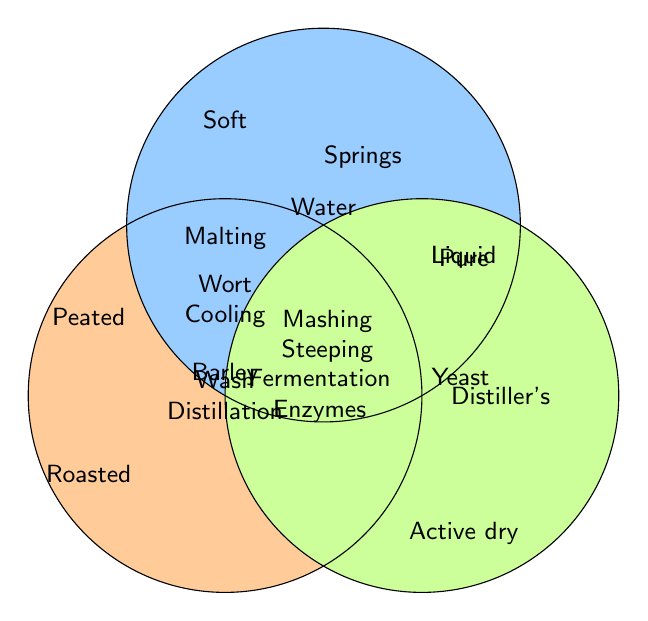What are the main ingredients shown in the Venn Diagram? The Venn Diagram shows three main ingredients as labeled segments: Barley, Water, and Yeast.
Answer: Barley, Water, Yeast Which ingredient is associated with the process 'Springs'? The process 'Springs' is placed inside the circle labeled 'Water'.
Answer: Water Which processes are shared by Barley and Yeast but not Water? The shared processes for Barley and Yeast but not Water are listed in the section overlapping Barley and Yeast circles: Mashing and Steeping.
Answer: Mashing, Steeping How many processes are exclusive to Yeast? The processes exclusive to Yeast are listed inside the Yeast circle but not overlapping with others: Distiller’s, Active dry, Liquid.
Answer: 3 Which processes are common to all three ingredients? The processes common to Barley, Water, and Yeast are listed in the very center of the Venn Diagram where all three circles overlap: Wash, Distillation.
Answer: Wash, Distillation What processes are shared between Water and Yeast but not Barley? The processes shared by Water and Yeast, but not Barley, are listed where Water and Yeast circles overlap: Wort and Cooling.
Answer: Wort, Cooling Are there any processes that are unique to Water? Yes, the processes listed inside the Water circle but not overlapping any others are: Springs, Soft, Pure.
Answer: Springs, Soft, Pure Compare the number of processes exclusive to Barley and Yeast, which ingredient has more exclusive processes? Barley has three exclusive processes: Malting, Peated, Roasted. Yeast also has three: Distiller's, Active dry, Liquid. Both have the same number of exclusive processes.
Answer: Both have the same 